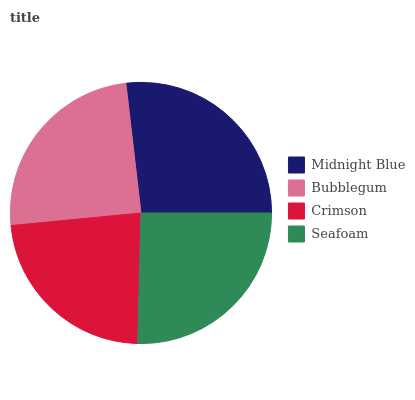Is Crimson the minimum?
Answer yes or no. Yes. Is Midnight Blue the maximum?
Answer yes or no. Yes. Is Bubblegum the minimum?
Answer yes or no. No. Is Bubblegum the maximum?
Answer yes or no. No. Is Midnight Blue greater than Bubblegum?
Answer yes or no. Yes. Is Bubblegum less than Midnight Blue?
Answer yes or no. Yes. Is Bubblegum greater than Midnight Blue?
Answer yes or no. No. Is Midnight Blue less than Bubblegum?
Answer yes or no. No. Is Seafoam the high median?
Answer yes or no. Yes. Is Bubblegum the low median?
Answer yes or no. Yes. Is Midnight Blue the high median?
Answer yes or no. No. Is Midnight Blue the low median?
Answer yes or no. No. 